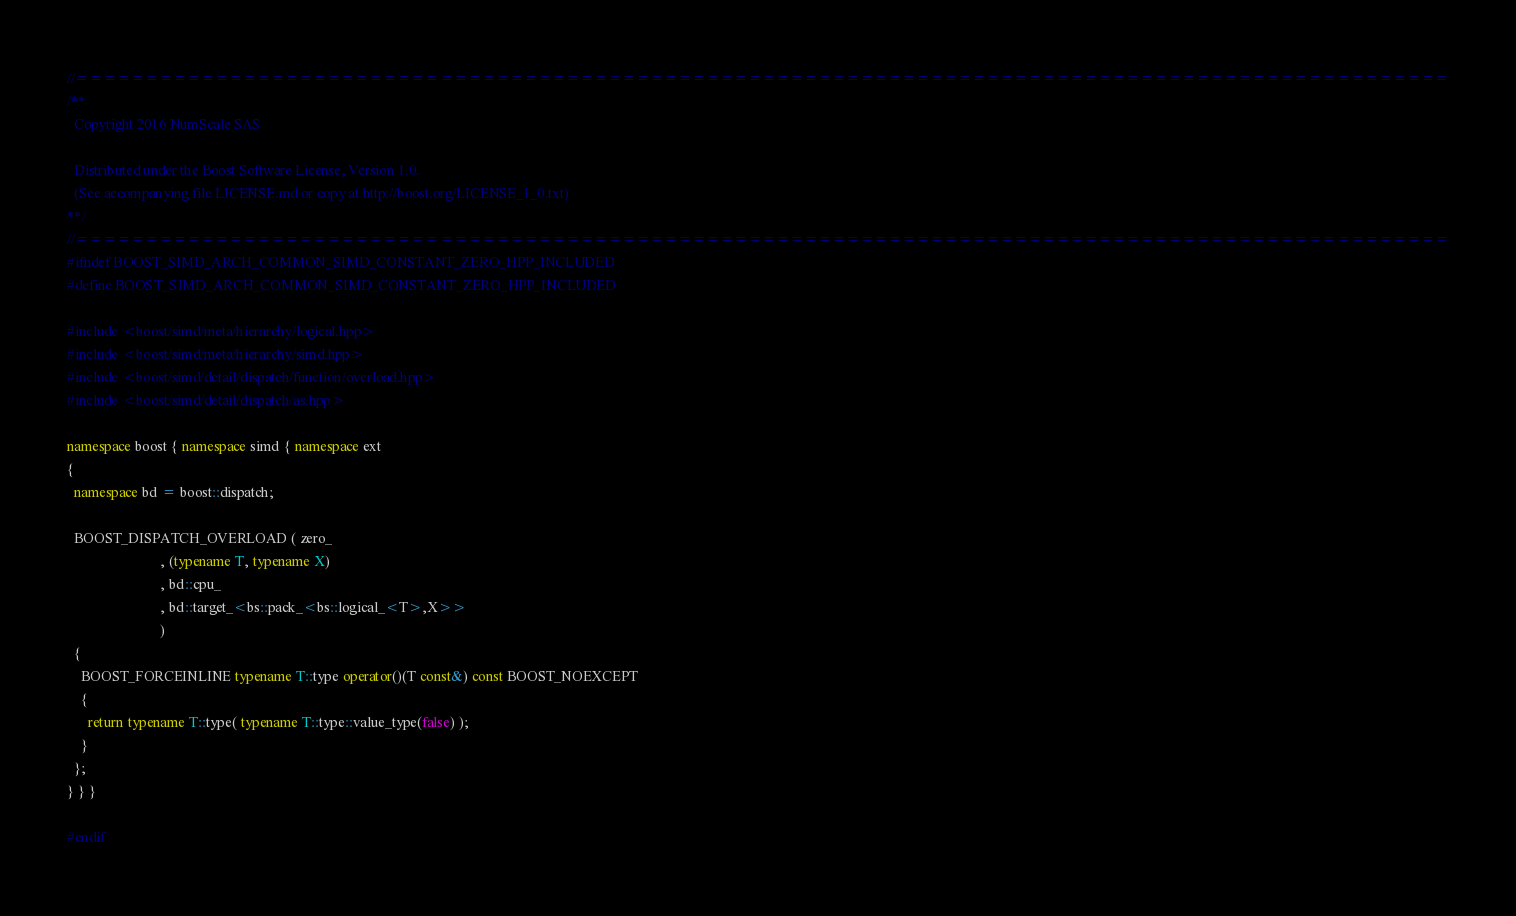Convert code to text. <code><loc_0><loc_0><loc_500><loc_500><_C++_>//==================================================================================================
/**
  Copyright 2016 NumScale SAS

  Distributed under the Boost Software License, Version 1.0.
  (See accompanying file LICENSE.md or copy at http://boost.org/LICENSE_1_0.txt)
**/
//==================================================================================================
#ifndef BOOST_SIMD_ARCH_COMMON_SIMD_CONSTANT_ZERO_HPP_INCLUDED
#define BOOST_SIMD_ARCH_COMMON_SIMD_CONSTANT_ZERO_HPP_INCLUDED

#include <boost/simd/meta/hierarchy/logical.hpp>
#include <boost/simd/meta/hierarchy/simd.hpp>
#include <boost/simd/detail/dispatch/function/overload.hpp>
#include <boost/simd/detail/dispatch/as.hpp>

namespace boost { namespace simd { namespace ext
{
  namespace bd = boost::dispatch;

  BOOST_DISPATCH_OVERLOAD ( zero_
                          , (typename T, typename X)
                          , bd::cpu_
                          , bd::target_<bs::pack_<bs::logical_<T>,X>>
                          )
  {
    BOOST_FORCEINLINE typename T::type operator()(T const&) const BOOST_NOEXCEPT
    {
      return typename T::type( typename T::type::value_type(false) );
    }
  };
} } }

#endif
</code> 